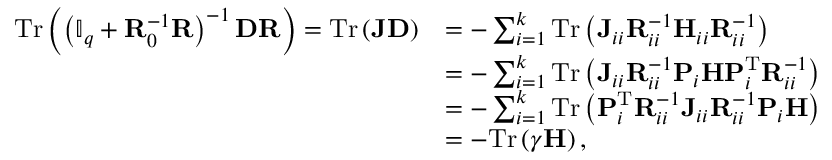Convert formula to latex. <formula><loc_0><loc_0><loc_500><loc_500>\begin{array} { r l } { T r \left ( \left ( \mathbb { I } _ { q } + R _ { 0 } ^ { - 1 } R \right ) ^ { - 1 } D R \right ) = T r \left ( J D \right ) } & { = - \sum _ { i = 1 } ^ { k } T r \left ( J _ { i i } R _ { i i } ^ { - 1 } H _ { i i } R _ { i i } ^ { - 1 } \right ) } \\ & { = - \sum _ { i = 1 } ^ { k } T r \left ( J _ { i i } R _ { i i } ^ { - 1 } P _ { i } H P _ { i } ^ { T } R _ { i i } ^ { - 1 } \right ) } \\ & { = - \sum _ { i = 1 } ^ { k } T r \left ( P _ { i } ^ { T } R _ { i i } ^ { - 1 } J _ { i i } R _ { i i } ^ { - 1 } P _ { i } H \right ) } \\ & { = - T r \left ( \gamma H \right ) , } \end{array}</formula> 